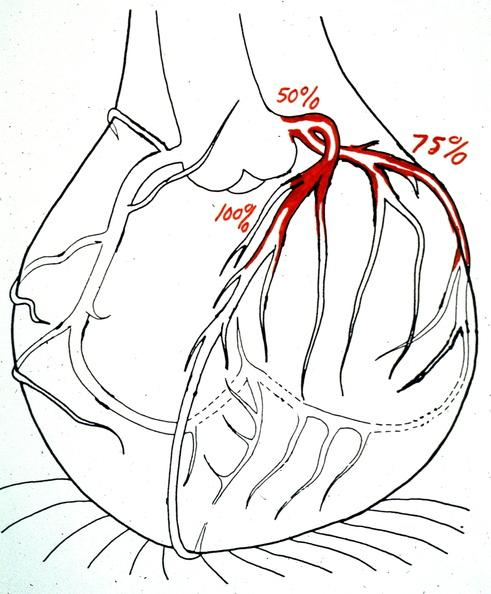s cardiovascular present?
Answer the question using a single word or phrase. Yes 